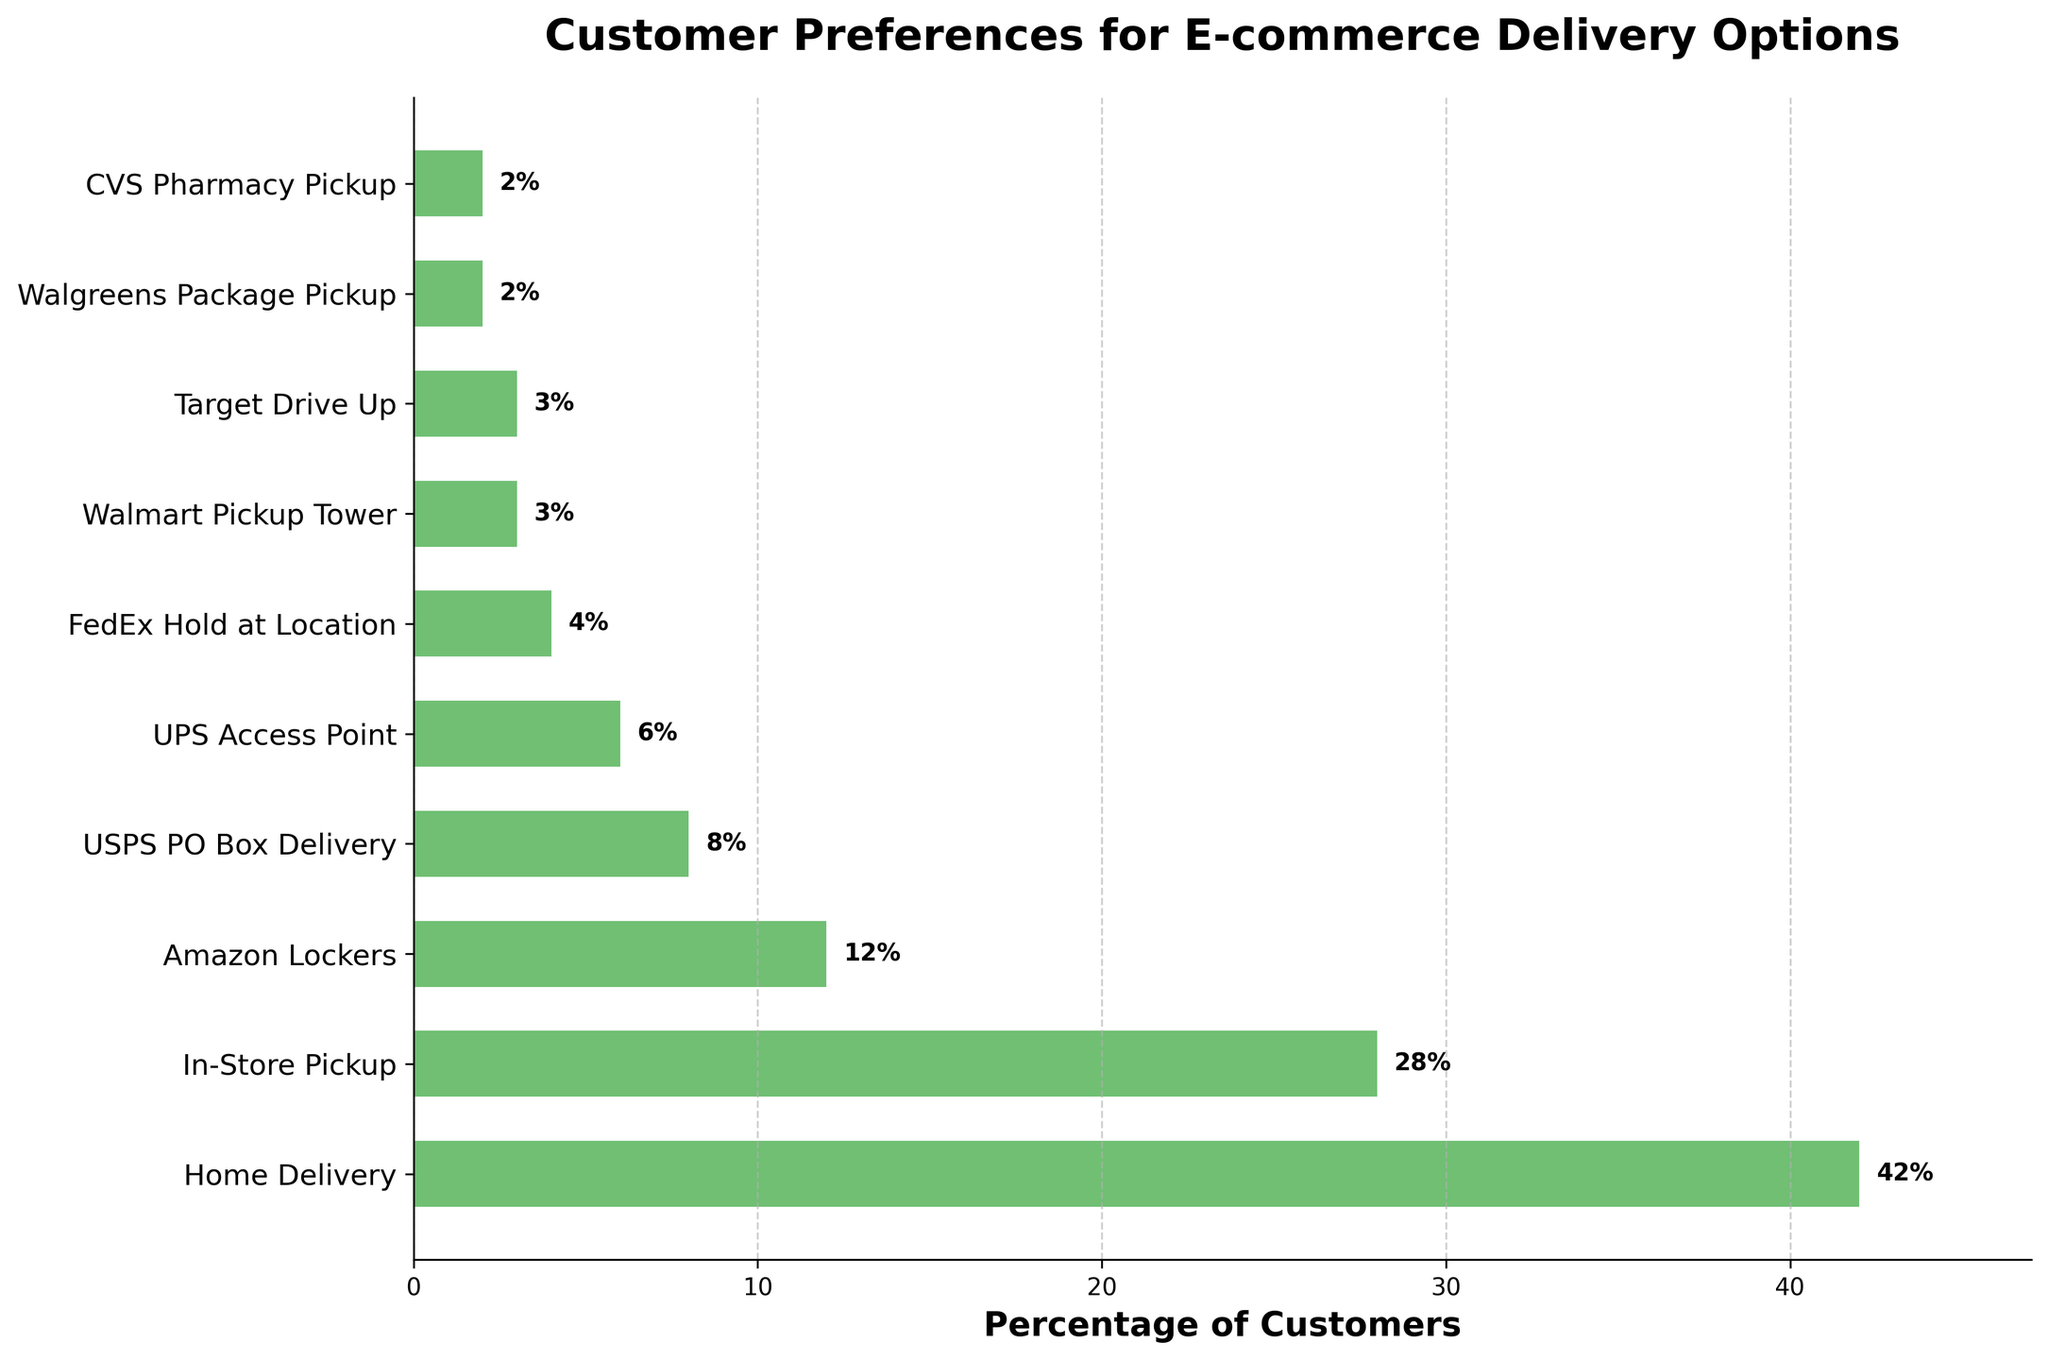What's the most preferred delivery option among customers? Look at the height and label of the bar that extends the farthest to the right, which represents the highest percentage. "Home Delivery" has the largest bar.
Answer: Home Delivery Which delivery options have a preference percentage higher than 10%? Identify the bars with labels showing percentages greater than 10%. "Home Delivery" (42%), "In-Store Pickup" (28%), and "Amazon Lockers" (12%) are the options with percentages above 10%.
Answer: Home Delivery, In-Store Pickup, Amazon Lockers What's the combined percentage of customers for 'Walmart Pickup Tower' and 'Target Drive Up'? Sum the percentages of "Walmart Pickup Tower" and "Target Drive Up", which are 3% each. So, 3% + 3% = 6%.
Answer: 6% Does 'FedEx Hold at Location' have a higher preference percentage than 'UPS Access Point'? Compare the bars for "FedEx Hold at Location" and "UPS Access Point". "FedEx Hold at Location" is 4%, which is less than "UPS Access Point" at 6%.
Answer: No Which two delivery options have the lowest preference percentages? Identify the two shortest bars with the smallest labels. "CVS Pharmacy Pickup" and "Walgreens Package Pickup" both have percentages of 2%, making them the lowest.
Answer: CVS Pharmacy Pickup and Walgreens Package Pickup How much more preferred is 'Home Delivery' compared to 'UPS Access Point'? Subtract the percentage for "UPS Access Point" (6%) from the percentage for "Home Delivery" (42%). 42% - 6% = 36%.
Answer: 36% Are there more customers who prefer 'In-Store Pickup' than the combined preference for 'USPS PO Box Delivery' and 'Amazon Lockers'? Compare "In-Store Pickup" (28%) with the sum of "USPS PO Box Delivery" (8%) and "Amazon Lockers" (12%). 8% + 12% = 20%, which is less than 28%.
Answer: Yes What percentage of customers prefer 'Amazon Lockers'? Read the label corresponding to "Amazon Lockers," which shows the percentage directly on the bar.
Answer: 12% What is the average preference percentage for 'Walmart Pickup Tower', 'Target Drive Up', and 'CVS Pharmacy Pickup'? Find the average by summing the percentages (3% + 3% + 2%) and dividing by the number of options (3). (3 + 3 + 2) / 3 = 8 / 3 ≈ 2.67%.
Answer: 2.67% What percentage of customers prefer delivery options that are pickup locations (sum of all percentages except 'Home Delivery')? Sum the percentages of all options except "Home Delivery" - (28% + 12% + 8% + 6% + 4% + 3% + 3% + 2% + 2% = 68%).
Answer: 68% 